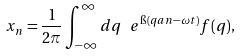Convert formula to latex. <formula><loc_0><loc_0><loc_500><loc_500>x _ { n } = \frac { 1 } { 2 \pi } \int _ { - \infty } ^ { \infty } d q \, \ e ^ { \i ( q a n - \omega t ) } f ( q ) ,</formula> 